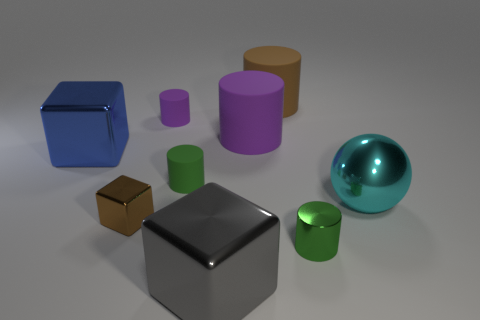Subtract all large brown cylinders. How many cylinders are left? 4 Add 1 tiny green cylinders. How many objects exist? 10 Subtract all blue cubes. How many cubes are left? 2 Subtract 2 blocks. How many blocks are left? 1 Subtract all cylinders. How many objects are left? 4 Add 9 big blue metallic blocks. How many big blue metallic blocks exist? 10 Subtract 0 yellow cylinders. How many objects are left? 9 Subtract all brown cubes. Subtract all blue balls. How many cubes are left? 2 Subtract all cyan blocks. How many gray balls are left? 0 Subtract all large cubes. Subtract all brown matte cylinders. How many objects are left? 6 